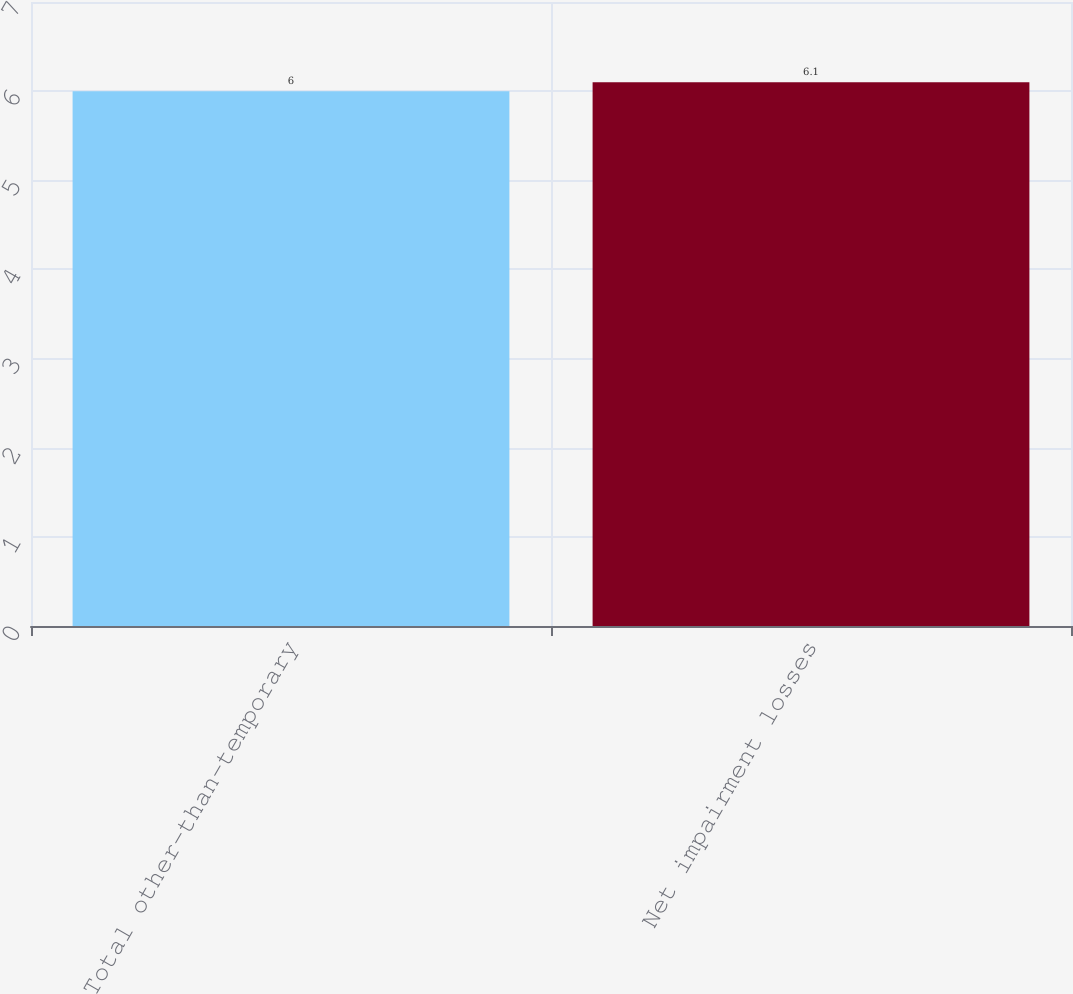Convert chart to OTSL. <chart><loc_0><loc_0><loc_500><loc_500><bar_chart><fcel>Total other-than-temporary<fcel>Net impairment losses<nl><fcel>6<fcel>6.1<nl></chart> 